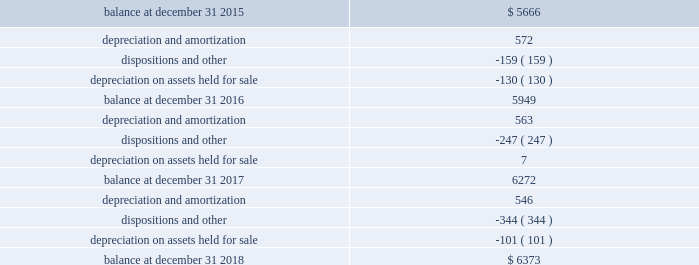Schedule iii page 6 of 6 host hotels & resorts , inc. , and subsidiaries host hotels & resorts , l.p. , and subsidiaries real estate and accumulated depreciation december 31 , 2018 ( in millions ) ( b ) the change in accumulated depreciation and amortization of real estate assets for the fiscal years ended december 31 , 2018 , 2017 and 2016 is as follows: .
( c ) the aggregate cost of real estate for federal income tax purposes is approximately $ 10458 million at december 31 , 2018 .
( d ) the total cost of properties excludes construction-in-progress properties. .
What was the net change in millions in the accumulated depreciation and amortization of real estate assets from 2016 to 2017? 
Computations: (6272 - 5949)
Answer: 323.0. Schedule iii page 6 of 6 host hotels & resorts , inc. , and subsidiaries host hotels & resorts , l.p. , and subsidiaries real estate and accumulated depreciation december 31 , 2018 ( in millions ) ( b ) the change in accumulated depreciation and amortization of real estate assets for the fiscal years ended december 31 , 2018 , 2017 and 2016 is as follows: .
( c ) the aggregate cost of real estate for federal income tax purposes is approximately $ 10458 million at december 31 , 2018 .
( d ) the total cost of properties excludes construction-in-progress properties. .
What was the net change in millions in the accumulated depreciation and amortization of real estate assets from 2015 to 2016? 
Computations: (5949 - 5666)
Answer: 283.0. 